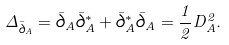Convert formula to latex. <formula><loc_0><loc_0><loc_500><loc_500>\Delta _ { \bar { \partial } _ { A } } = \bar { \partial } _ { A } \bar { \partial } _ { A } ^ { * } + \bar { \partial } _ { A } ^ { * } \bar { \partial } _ { A } = \frac { 1 } { 2 } D _ { A } ^ { 2 } .</formula> 